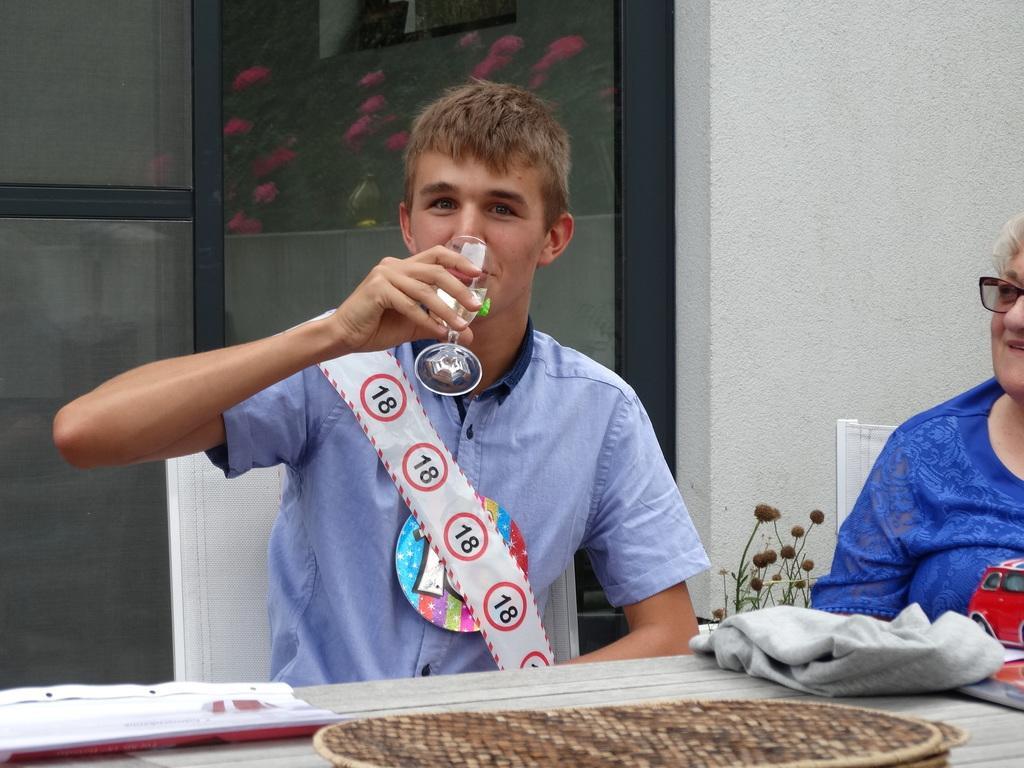Can you describe this image briefly? In the foreground of this image, there is a man sitting on the chair, holding a glass and wearing a sash ribbon. On the bottom, there is a table on which a file, a basket like an object, a toy car and a jacket is on it. On the right, there is a woman, a plant and a wall and there is also a glass door in the background. 